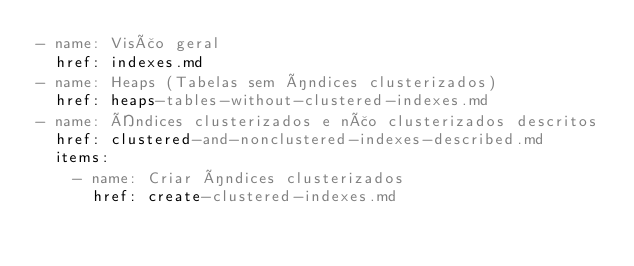<code> <loc_0><loc_0><loc_500><loc_500><_YAML_>- name: Visão geral
  href: indexes.md
- name: Heaps (Tabelas sem índices clusterizados)
  href: heaps-tables-without-clustered-indexes.md
- name: Índices clusterizados e não clusterizados descritos
  href: clustered-and-nonclustered-indexes-described.md
  items:
    - name: Criar índices clusterizados
      href: create-clustered-indexes.md</code> 